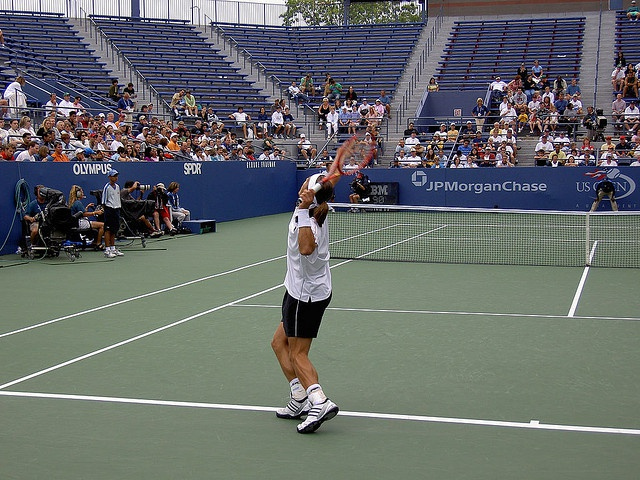Describe the objects in this image and their specific colors. I can see people in lightgray, black, gray, navy, and darkgray tones, people in lightgray, black, darkgray, lavender, and gray tones, tennis racket in lightgray, brown, gray, maroon, and black tones, people in lightgray, black, darkgray, gray, and maroon tones, and chair in lightgray, black, gray, navy, and blue tones in this image. 